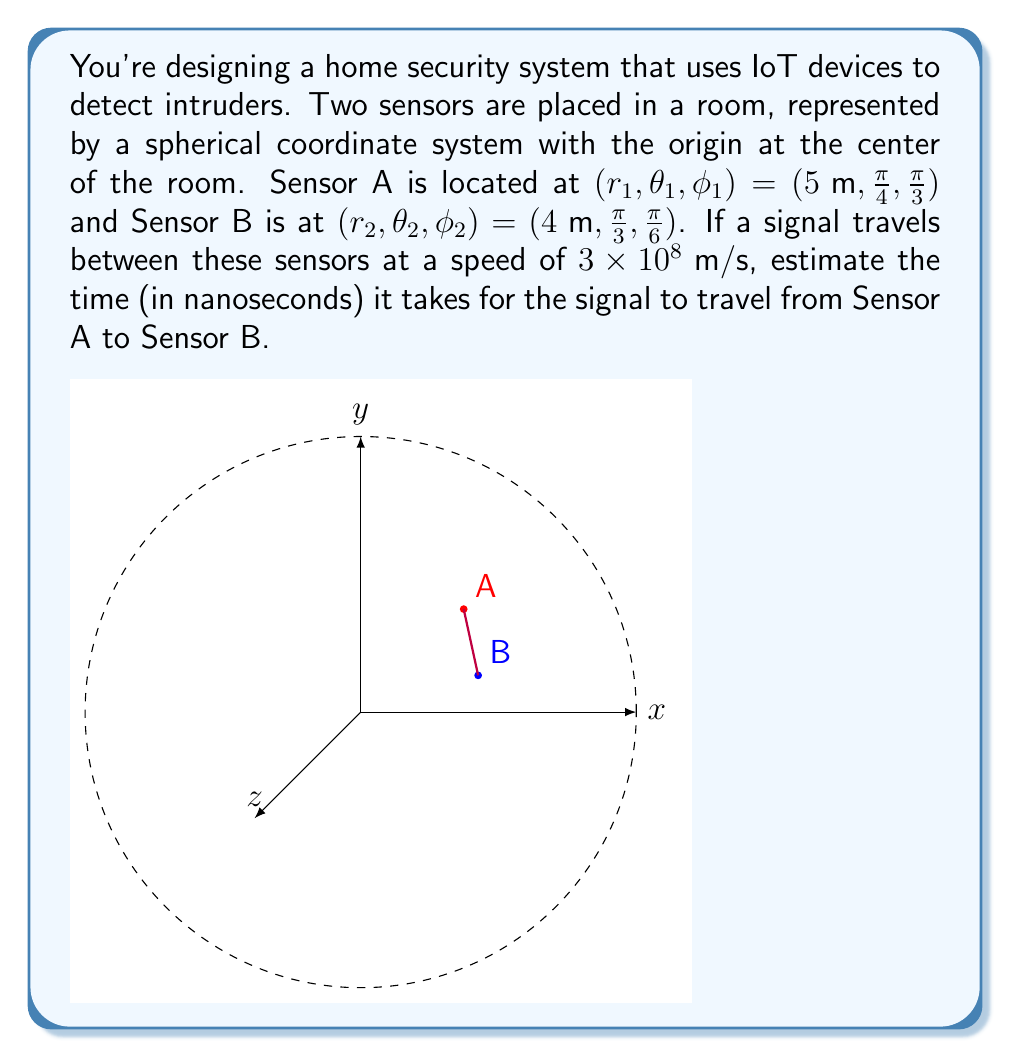Solve this math problem. To solve this problem, we need to follow these steps:

1) First, we need to convert the spherical coordinates to Cartesian coordinates for both sensors:

   For Sensor A $(5, \frac{\pi}{4}, \frac{\pi}{3})$:
   $$x_1 = r_1 \sin\phi_1 \cos\theta_1 = 5 \sin(\frac{\pi}{3}) \cos(\frac{\pi}{4}) = \frac{5\sqrt{6}}{4}$$
   $$y_1 = r_1 \sin\phi_1 \sin\theta_1 = 5 \sin(\frac{\pi}{3}) \sin(\frac{\pi}{4}) = \frac{5\sqrt{6}}{4}$$
   $$z_1 = r_1 \cos\phi_1 = 5 \cos(\frac{\pi}{3}) = \frac{5\sqrt{3}}{2}$$

   For Sensor B $(4, \frac{\pi}{3}, \frac{\pi}{6})$:
   $$x_2 = r_2 \sin\phi_2 \cos\theta_2 = 4 \sin(\frac{\pi}{6}) \cos(\frac{\pi}{3}) = 2\sqrt{3}$$
   $$y_2 = r_2 \sin\phi_2 \sin\theta_2 = 4 \sin(\frac{\pi}{6}) \sin(\frac{\pi}{3}) = 2$$
   $$z_2 = r_2 \cos\phi_2 = 4 \cos(\frac{\pi}{6}) = 2\sqrt{3}$$

2) Now, we can calculate the distance between the two sensors using the distance formula in 3D space:

   $$d = \sqrt{(x_2-x_1)^2 + (y_2-y_1)^2 + (z_2-z_1)^2}$$
   
   $$d = \sqrt{(2\sqrt{3}-\frac{5\sqrt{6}}{4})^2 + (2-\frac{5\sqrt{6}}{4})^2 + (2\sqrt{3}-\frac{5\sqrt{3}}{2})^2}$$

3) Simplify and calculate:
   
   $$d \approx 2.86\text{ m}$$

4) Now, we can use the formula: Time = Distance / Speed

   $$t = \frac{d}{v} = \frac{2.86}{3 \times 10^8} \approx 9.53 \times 10^{-9}\text{ s}$$

5) Convert to nanoseconds:

   $$t \approx 9.53\text{ ns}$$
Answer: $9.53\text{ ns}$ 